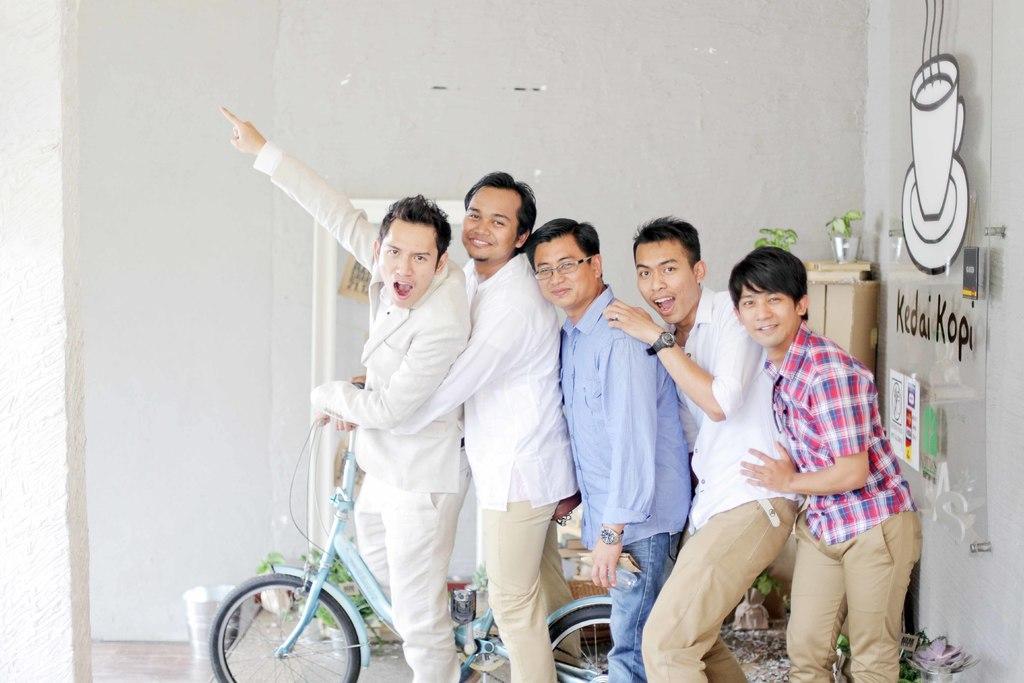Could you give a brief overview of what you see in this image? Five boys are posing to camera standing with a bicycle. 